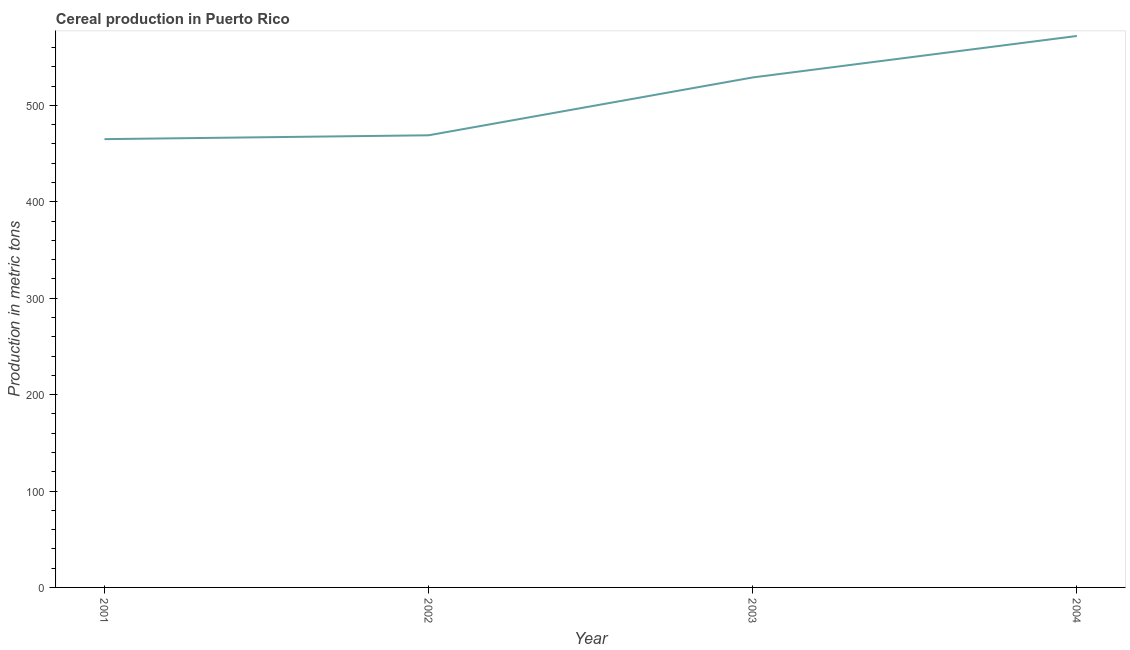What is the cereal production in 2004?
Make the answer very short. 572. Across all years, what is the maximum cereal production?
Offer a very short reply. 572. Across all years, what is the minimum cereal production?
Your answer should be very brief. 465. In which year was the cereal production maximum?
Your answer should be very brief. 2004. In which year was the cereal production minimum?
Provide a short and direct response. 2001. What is the sum of the cereal production?
Give a very brief answer. 2035. What is the difference between the cereal production in 2001 and 2003?
Provide a succinct answer. -64. What is the average cereal production per year?
Your answer should be very brief. 508.75. What is the median cereal production?
Your response must be concise. 499. In how many years, is the cereal production greater than 340 metric tons?
Provide a succinct answer. 4. Do a majority of the years between 2001 and 2004 (inclusive) have cereal production greater than 480 metric tons?
Your response must be concise. No. What is the ratio of the cereal production in 2001 to that in 2003?
Ensure brevity in your answer.  0.88. Is the difference between the cereal production in 2001 and 2004 greater than the difference between any two years?
Your answer should be compact. Yes. What is the difference between the highest and the lowest cereal production?
Your answer should be compact. 107. Does the cereal production monotonically increase over the years?
Give a very brief answer. Yes. How many lines are there?
Your answer should be compact. 1. Are the values on the major ticks of Y-axis written in scientific E-notation?
Offer a very short reply. No. Does the graph contain any zero values?
Your response must be concise. No. Does the graph contain grids?
Keep it short and to the point. No. What is the title of the graph?
Your answer should be very brief. Cereal production in Puerto Rico. What is the label or title of the Y-axis?
Keep it short and to the point. Production in metric tons. What is the Production in metric tons in 2001?
Ensure brevity in your answer.  465. What is the Production in metric tons of 2002?
Provide a short and direct response. 469. What is the Production in metric tons of 2003?
Make the answer very short. 529. What is the Production in metric tons in 2004?
Your answer should be compact. 572. What is the difference between the Production in metric tons in 2001 and 2002?
Offer a very short reply. -4. What is the difference between the Production in metric tons in 2001 and 2003?
Give a very brief answer. -64. What is the difference between the Production in metric tons in 2001 and 2004?
Give a very brief answer. -107. What is the difference between the Production in metric tons in 2002 and 2003?
Make the answer very short. -60. What is the difference between the Production in metric tons in 2002 and 2004?
Your answer should be compact. -103. What is the difference between the Production in metric tons in 2003 and 2004?
Provide a short and direct response. -43. What is the ratio of the Production in metric tons in 2001 to that in 2003?
Your answer should be very brief. 0.88. What is the ratio of the Production in metric tons in 2001 to that in 2004?
Ensure brevity in your answer.  0.81. What is the ratio of the Production in metric tons in 2002 to that in 2003?
Offer a terse response. 0.89. What is the ratio of the Production in metric tons in 2002 to that in 2004?
Your answer should be compact. 0.82. What is the ratio of the Production in metric tons in 2003 to that in 2004?
Provide a short and direct response. 0.93. 